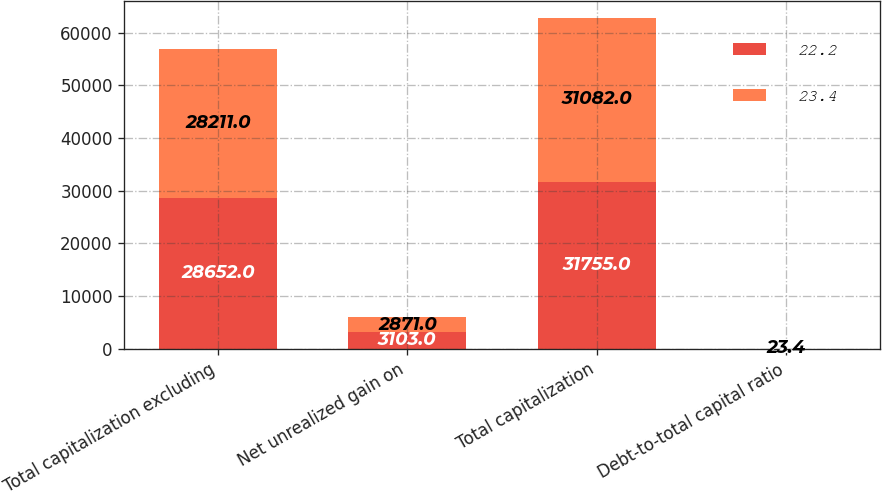Convert chart. <chart><loc_0><loc_0><loc_500><loc_500><stacked_bar_chart><ecel><fcel>Total capitalization excluding<fcel>Net unrealized gain on<fcel>Total capitalization<fcel>Debt-to-total capital ratio<nl><fcel>22.2<fcel>28652<fcel>3103<fcel>31755<fcel>22.2<nl><fcel>23.4<fcel>28211<fcel>2871<fcel>31082<fcel>23.4<nl></chart> 